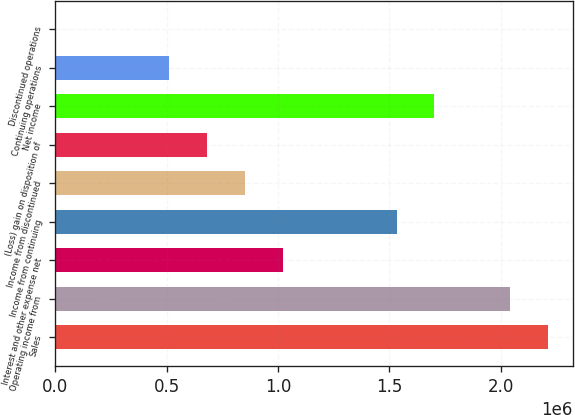<chart> <loc_0><loc_0><loc_500><loc_500><bar_chart><fcel>Sales<fcel>Operating income from<fcel>Interest and other expense net<fcel>Income from continuing<fcel>Income from discontinued<fcel>(Loss) gain on disposition of<fcel>Net income<fcel>Continuing operations<fcel>Discontinued operations<nl><fcel>2.21309e+06<fcel>2.04285e+06<fcel>1.02142e+06<fcel>1.53214e+06<fcel>851187<fcel>680950<fcel>1.70237e+06<fcel>510712<fcel>0.01<nl></chart> 